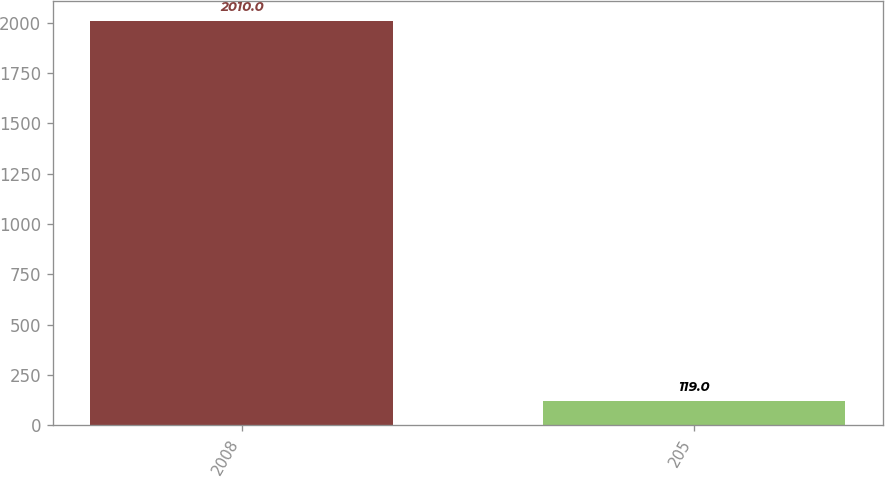Convert chart to OTSL. <chart><loc_0><loc_0><loc_500><loc_500><bar_chart><fcel>2008<fcel>205<nl><fcel>2010<fcel>119<nl></chart> 